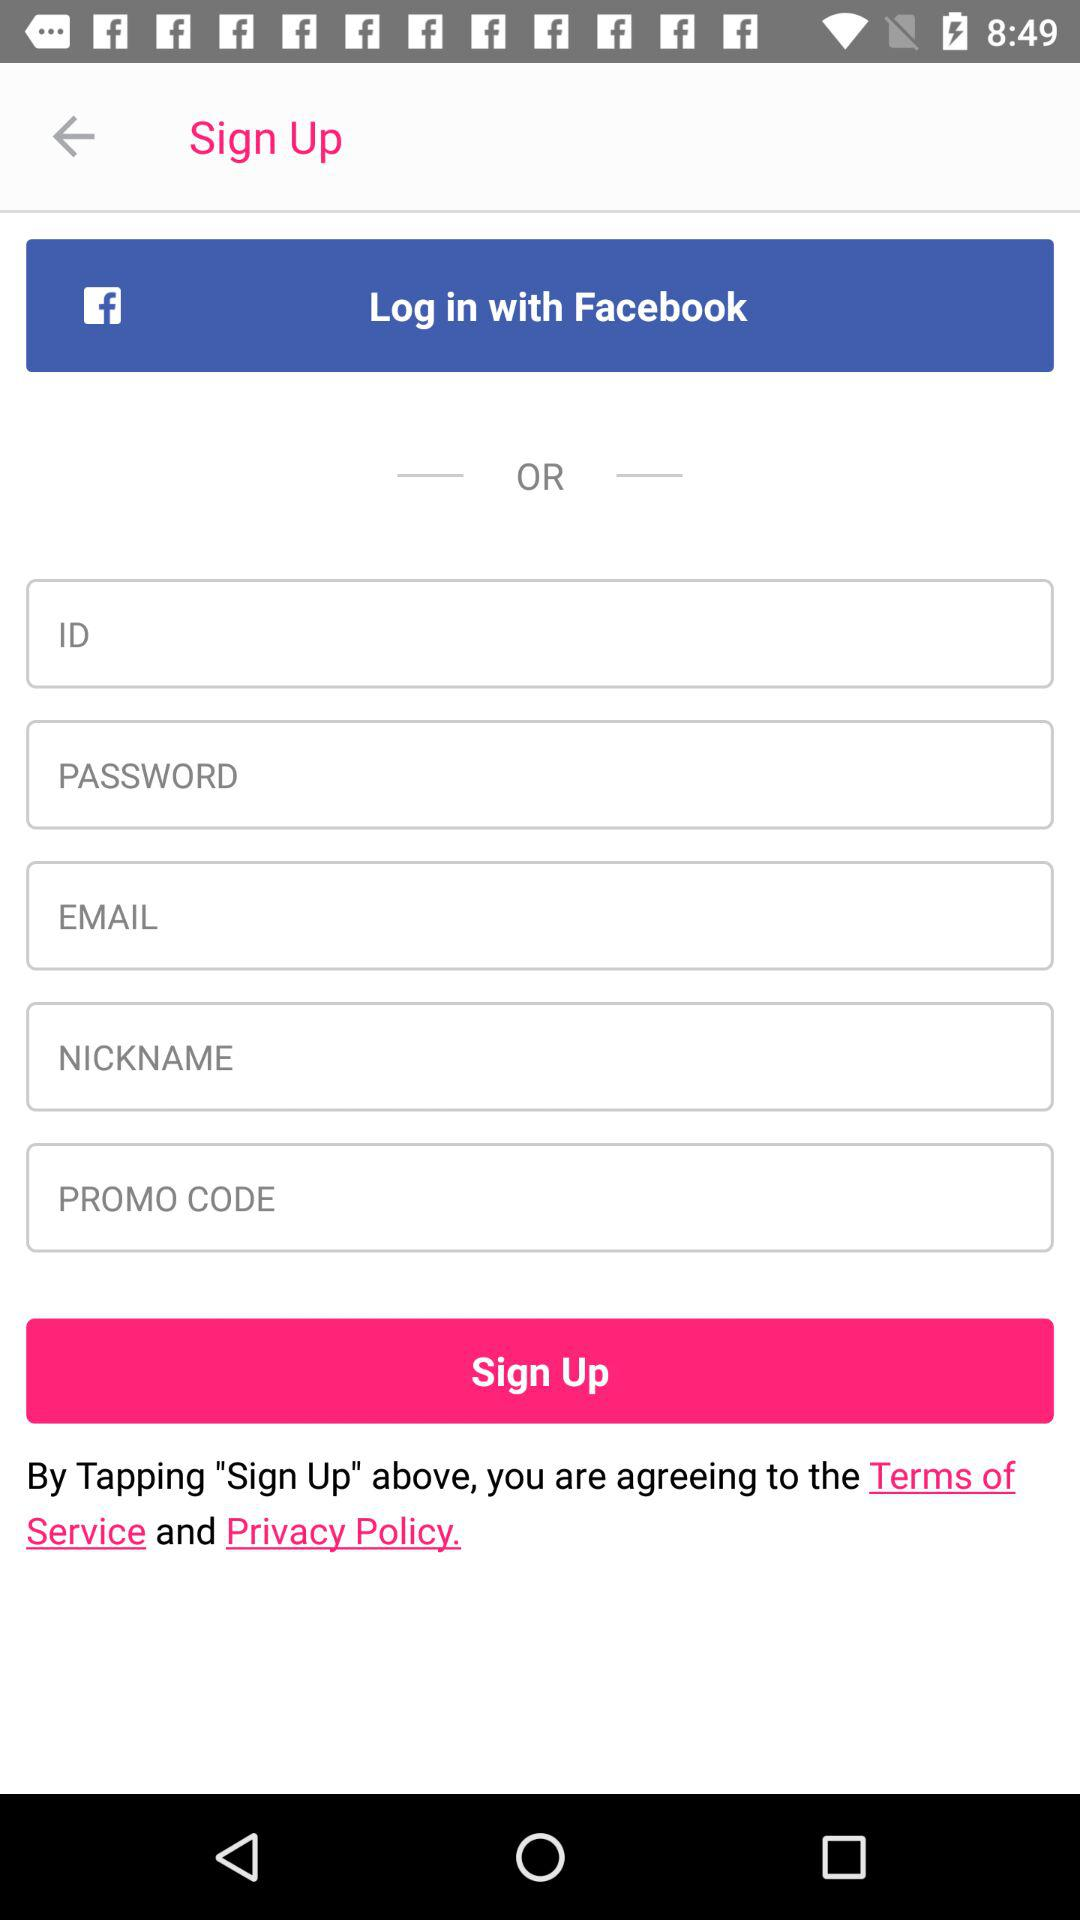What is the given number of "Reine"? The given number is 21,000. 